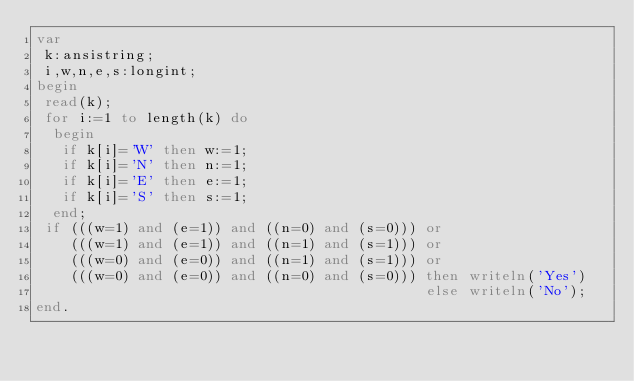<code> <loc_0><loc_0><loc_500><loc_500><_Pascal_>var
 k:ansistring;
 i,w,n,e,s:longint;
begin
 read(k);
 for i:=1 to length(k) do
  begin
   if k[i]='W' then w:=1;
   if k[i]='N' then n:=1;
   if k[i]='E' then e:=1;
   if k[i]='S' then s:=1;
  end;
 if (((w=1) and (e=1)) and ((n=0) and (s=0))) or
    (((w=1) and (e=1)) and ((n=1) and (s=1))) or
    (((w=0) and (e=0)) and ((n=1) and (s=1))) or
    (((w=0) and (e=0)) and ((n=0) and (s=0))) then writeln('Yes')
                                              else writeln('No');
end.</code> 